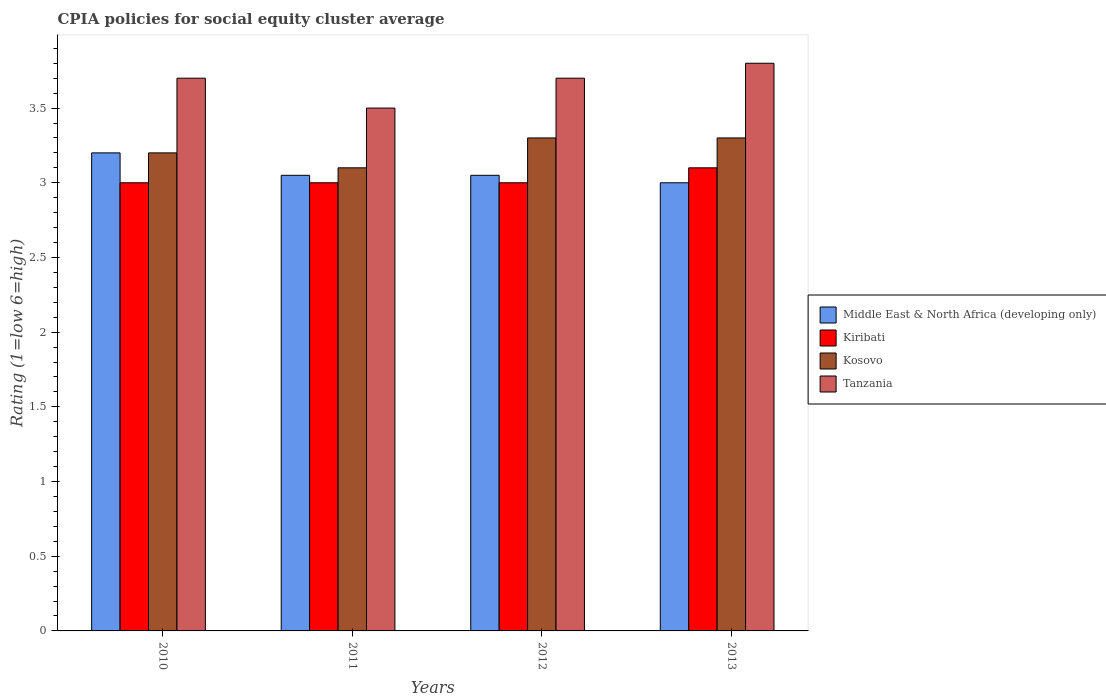How many different coloured bars are there?
Provide a short and direct response. 4. Are the number of bars per tick equal to the number of legend labels?
Keep it short and to the point. Yes. What is the label of the 4th group of bars from the left?
Make the answer very short. 2013. Across all years, what is the minimum CPIA rating in Tanzania?
Offer a very short reply. 3.5. In which year was the CPIA rating in Middle East & North Africa (developing only) maximum?
Give a very brief answer. 2010. What is the total CPIA rating in Kiribati in the graph?
Provide a short and direct response. 12.1. What is the difference between the CPIA rating in Tanzania in 2012 and that in 2013?
Your answer should be compact. -0.1. What is the difference between the CPIA rating in Middle East & North Africa (developing only) in 2011 and the CPIA rating in Tanzania in 2010?
Keep it short and to the point. -0.65. What is the average CPIA rating in Middle East & North Africa (developing only) per year?
Provide a succinct answer. 3.08. In how many years, is the CPIA rating in Tanzania greater than 1.5?
Your response must be concise. 4. What is the ratio of the CPIA rating in Kosovo in 2010 to that in 2012?
Offer a very short reply. 0.97. Is the difference between the CPIA rating in Tanzania in 2010 and 2013 greater than the difference between the CPIA rating in Kosovo in 2010 and 2013?
Give a very brief answer. No. What is the difference between the highest and the second highest CPIA rating in Tanzania?
Give a very brief answer. 0.1. What is the difference between the highest and the lowest CPIA rating in Middle East & North Africa (developing only)?
Provide a short and direct response. 0.2. Is the sum of the CPIA rating in Kiribati in 2010 and 2012 greater than the maximum CPIA rating in Tanzania across all years?
Make the answer very short. Yes. Is it the case that in every year, the sum of the CPIA rating in Kosovo and CPIA rating in Tanzania is greater than the sum of CPIA rating in Kiribati and CPIA rating in Middle East & North Africa (developing only)?
Your response must be concise. Yes. What does the 1st bar from the left in 2010 represents?
Keep it short and to the point. Middle East & North Africa (developing only). What does the 3rd bar from the right in 2013 represents?
Keep it short and to the point. Kiribati. How many bars are there?
Keep it short and to the point. 16. Are the values on the major ticks of Y-axis written in scientific E-notation?
Provide a succinct answer. No. Does the graph contain any zero values?
Provide a succinct answer. No. Does the graph contain grids?
Offer a very short reply. No. Where does the legend appear in the graph?
Ensure brevity in your answer.  Center right. How many legend labels are there?
Make the answer very short. 4. What is the title of the graph?
Offer a terse response. CPIA policies for social equity cluster average. What is the label or title of the X-axis?
Provide a succinct answer. Years. What is the Rating (1=low 6=high) in Kiribati in 2010?
Offer a terse response. 3. What is the Rating (1=low 6=high) in Kosovo in 2010?
Offer a very short reply. 3.2. What is the Rating (1=low 6=high) in Middle East & North Africa (developing only) in 2011?
Your response must be concise. 3.05. What is the Rating (1=low 6=high) in Kiribati in 2011?
Make the answer very short. 3. What is the Rating (1=low 6=high) of Middle East & North Africa (developing only) in 2012?
Provide a succinct answer. 3.05. What is the Rating (1=low 6=high) in Kiribati in 2012?
Your answer should be compact. 3. What is the Rating (1=low 6=high) of Middle East & North Africa (developing only) in 2013?
Provide a succinct answer. 3. Across all years, what is the maximum Rating (1=low 6=high) in Kiribati?
Provide a short and direct response. 3.1. Across all years, what is the maximum Rating (1=low 6=high) of Kosovo?
Make the answer very short. 3.3. Across all years, what is the maximum Rating (1=low 6=high) of Tanzania?
Your response must be concise. 3.8. Across all years, what is the minimum Rating (1=low 6=high) of Kiribati?
Your response must be concise. 3. Across all years, what is the minimum Rating (1=low 6=high) of Kosovo?
Give a very brief answer. 3.1. What is the total Rating (1=low 6=high) of Middle East & North Africa (developing only) in the graph?
Your answer should be compact. 12.3. What is the total Rating (1=low 6=high) of Kiribati in the graph?
Give a very brief answer. 12.1. What is the total Rating (1=low 6=high) of Kosovo in the graph?
Provide a succinct answer. 12.9. What is the difference between the Rating (1=low 6=high) of Kiribati in 2010 and that in 2011?
Offer a very short reply. 0. What is the difference between the Rating (1=low 6=high) in Middle East & North Africa (developing only) in 2010 and that in 2012?
Give a very brief answer. 0.15. What is the difference between the Rating (1=low 6=high) of Kiribati in 2010 and that in 2012?
Keep it short and to the point. 0. What is the difference between the Rating (1=low 6=high) of Tanzania in 2010 and that in 2012?
Keep it short and to the point. 0. What is the difference between the Rating (1=low 6=high) in Middle East & North Africa (developing only) in 2010 and that in 2013?
Give a very brief answer. 0.2. What is the difference between the Rating (1=low 6=high) of Tanzania in 2010 and that in 2013?
Keep it short and to the point. -0.1. What is the difference between the Rating (1=low 6=high) in Middle East & North Africa (developing only) in 2011 and that in 2013?
Make the answer very short. 0.05. What is the difference between the Rating (1=low 6=high) of Kosovo in 2011 and that in 2013?
Keep it short and to the point. -0.2. What is the difference between the Rating (1=low 6=high) in Tanzania in 2011 and that in 2013?
Give a very brief answer. -0.3. What is the difference between the Rating (1=low 6=high) of Middle East & North Africa (developing only) in 2012 and that in 2013?
Provide a succinct answer. 0.05. What is the difference between the Rating (1=low 6=high) of Kosovo in 2012 and that in 2013?
Your answer should be very brief. 0. What is the difference between the Rating (1=low 6=high) in Tanzania in 2012 and that in 2013?
Your answer should be very brief. -0.1. What is the difference between the Rating (1=low 6=high) of Middle East & North Africa (developing only) in 2010 and the Rating (1=low 6=high) of Tanzania in 2011?
Keep it short and to the point. -0.3. What is the difference between the Rating (1=low 6=high) in Kosovo in 2010 and the Rating (1=low 6=high) in Tanzania in 2011?
Your response must be concise. -0.3. What is the difference between the Rating (1=low 6=high) of Middle East & North Africa (developing only) in 2010 and the Rating (1=low 6=high) of Tanzania in 2012?
Give a very brief answer. -0.5. What is the difference between the Rating (1=low 6=high) in Kiribati in 2010 and the Rating (1=low 6=high) in Kosovo in 2013?
Ensure brevity in your answer.  -0.3. What is the difference between the Rating (1=low 6=high) in Middle East & North Africa (developing only) in 2011 and the Rating (1=low 6=high) in Tanzania in 2012?
Your answer should be compact. -0.65. What is the difference between the Rating (1=low 6=high) of Kosovo in 2011 and the Rating (1=low 6=high) of Tanzania in 2012?
Give a very brief answer. -0.6. What is the difference between the Rating (1=low 6=high) in Middle East & North Africa (developing only) in 2011 and the Rating (1=low 6=high) in Tanzania in 2013?
Give a very brief answer. -0.75. What is the difference between the Rating (1=low 6=high) of Kiribati in 2011 and the Rating (1=low 6=high) of Kosovo in 2013?
Provide a succinct answer. -0.3. What is the difference between the Rating (1=low 6=high) of Kiribati in 2011 and the Rating (1=low 6=high) of Tanzania in 2013?
Your answer should be very brief. -0.8. What is the difference between the Rating (1=low 6=high) in Kosovo in 2011 and the Rating (1=low 6=high) in Tanzania in 2013?
Provide a short and direct response. -0.7. What is the difference between the Rating (1=low 6=high) in Middle East & North Africa (developing only) in 2012 and the Rating (1=low 6=high) in Kiribati in 2013?
Give a very brief answer. -0.05. What is the difference between the Rating (1=low 6=high) of Middle East & North Africa (developing only) in 2012 and the Rating (1=low 6=high) of Tanzania in 2013?
Give a very brief answer. -0.75. What is the difference between the Rating (1=low 6=high) of Kiribati in 2012 and the Rating (1=low 6=high) of Kosovo in 2013?
Your response must be concise. -0.3. What is the average Rating (1=low 6=high) of Middle East & North Africa (developing only) per year?
Offer a very short reply. 3.08. What is the average Rating (1=low 6=high) of Kiribati per year?
Make the answer very short. 3.02. What is the average Rating (1=low 6=high) of Kosovo per year?
Your answer should be very brief. 3.23. What is the average Rating (1=low 6=high) in Tanzania per year?
Ensure brevity in your answer.  3.67. In the year 2010, what is the difference between the Rating (1=low 6=high) of Middle East & North Africa (developing only) and Rating (1=low 6=high) of Kiribati?
Offer a terse response. 0.2. In the year 2010, what is the difference between the Rating (1=low 6=high) in Middle East & North Africa (developing only) and Rating (1=low 6=high) in Kosovo?
Give a very brief answer. 0. In the year 2010, what is the difference between the Rating (1=low 6=high) in Middle East & North Africa (developing only) and Rating (1=low 6=high) in Tanzania?
Give a very brief answer. -0.5. In the year 2010, what is the difference between the Rating (1=low 6=high) of Kiribati and Rating (1=low 6=high) of Tanzania?
Your answer should be compact. -0.7. In the year 2010, what is the difference between the Rating (1=low 6=high) of Kosovo and Rating (1=low 6=high) of Tanzania?
Provide a short and direct response. -0.5. In the year 2011, what is the difference between the Rating (1=low 6=high) of Middle East & North Africa (developing only) and Rating (1=low 6=high) of Kiribati?
Your answer should be very brief. 0.05. In the year 2011, what is the difference between the Rating (1=low 6=high) of Middle East & North Africa (developing only) and Rating (1=low 6=high) of Kosovo?
Give a very brief answer. -0.05. In the year 2011, what is the difference between the Rating (1=low 6=high) of Middle East & North Africa (developing only) and Rating (1=low 6=high) of Tanzania?
Your answer should be compact. -0.45. In the year 2011, what is the difference between the Rating (1=low 6=high) in Kiribati and Rating (1=low 6=high) in Kosovo?
Your answer should be very brief. -0.1. In the year 2012, what is the difference between the Rating (1=low 6=high) of Middle East & North Africa (developing only) and Rating (1=low 6=high) of Tanzania?
Offer a terse response. -0.65. In the year 2013, what is the difference between the Rating (1=low 6=high) in Middle East & North Africa (developing only) and Rating (1=low 6=high) in Kiribati?
Your response must be concise. -0.1. In the year 2013, what is the difference between the Rating (1=low 6=high) of Middle East & North Africa (developing only) and Rating (1=low 6=high) of Kosovo?
Make the answer very short. -0.3. In the year 2013, what is the difference between the Rating (1=low 6=high) of Middle East & North Africa (developing only) and Rating (1=low 6=high) of Tanzania?
Offer a very short reply. -0.8. In the year 2013, what is the difference between the Rating (1=low 6=high) of Kiribati and Rating (1=low 6=high) of Kosovo?
Offer a very short reply. -0.2. In the year 2013, what is the difference between the Rating (1=low 6=high) in Kiribati and Rating (1=low 6=high) in Tanzania?
Provide a succinct answer. -0.7. In the year 2013, what is the difference between the Rating (1=low 6=high) in Kosovo and Rating (1=low 6=high) in Tanzania?
Give a very brief answer. -0.5. What is the ratio of the Rating (1=low 6=high) in Middle East & North Africa (developing only) in 2010 to that in 2011?
Give a very brief answer. 1.05. What is the ratio of the Rating (1=low 6=high) of Kosovo in 2010 to that in 2011?
Provide a succinct answer. 1.03. What is the ratio of the Rating (1=low 6=high) in Tanzania in 2010 to that in 2011?
Keep it short and to the point. 1.06. What is the ratio of the Rating (1=low 6=high) in Middle East & North Africa (developing only) in 2010 to that in 2012?
Ensure brevity in your answer.  1.05. What is the ratio of the Rating (1=low 6=high) of Kosovo in 2010 to that in 2012?
Your answer should be very brief. 0.97. What is the ratio of the Rating (1=low 6=high) in Tanzania in 2010 to that in 2012?
Provide a short and direct response. 1. What is the ratio of the Rating (1=low 6=high) of Middle East & North Africa (developing only) in 2010 to that in 2013?
Provide a succinct answer. 1.07. What is the ratio of the Rating (1=low 6=high) in Kiribati in 2010 to that in 2013?
Offer a very short reply. 0.97. What is the ratio of the Rating (1=low 6=high) of Kosovo in 2010 to that in 2013?
Offer a very short reply. 0.97. What is the ratio of the Rating (1=low 6=high) of Tanzania in 2010 to that in 2013?
Provide a succinct answer. 0.97. What is the ratio of the Rating (1=low 6=high) of Middle East & North Africa (developing only) in 2011 to that in 2012?
Your answer should be very brief. 1. What is the ratio of the Rating (1=low 6=high) of Kosovo in 2011 to that in 2012?
Your answer should be compact. 0.94. What is the ratio of the Rating (1=low 6=high) of Tanzania in 2011 to that in 2012?
Offer a very short reply. 0.95. What is the ratio of the Rating (1=low 6=high) in Middle East & North Africa (developing only) in 2011 to that in 2013?
Offer a very short reply. 1.02. What is the ratio of the Rating (1=low 6=high) of Kiribati in 2011 to that in 2013?
Keep it short and to the point. 0.97. What is the ratio of the Rating (1=low 6=high) of Kosovo in 2011 to that in 2013?
Make the answer very short. 0.94. What is the ratio of the Rating (1=low 6=high) in Tanzania in 2011 to that in 2013?
Offer a very short reply. 0.92. What is the ratio of the Rating (1=low 6=high) in Middle East & North Africa (developing only) in 2012 to that in 2013?
Ensure brevity in your answer.  1.02. What is the ratio of the Rating (1=low 6=high) in Tanzania in 2012 to that in 2013?
Make the answer very short. 0.97. What is the difference between the highest and the second highest Rating (1=low 6=high) in Middle East & North Africa (developing only)?
Make the answer very short. 0.15. What is the difference between the highest and the second highest Rating (1=low 6=high) in Kosovo?
Make the answer very short. 0. What is the difference between the highest and the lowest Rating (1=low 6=high) of Middle East & North Africa (developing only)?
Ensure brevity in your answer.  0.2. What is the difference between the highest and the lowest Rating (1=low 6=high) in Kosovo?
Ensure brevity in your answer.  0.2. What is the difference between the highest and the lowest Rating (1=low 6=high) of Tanzania?
Ensure brevity in your answer.  0.3. 